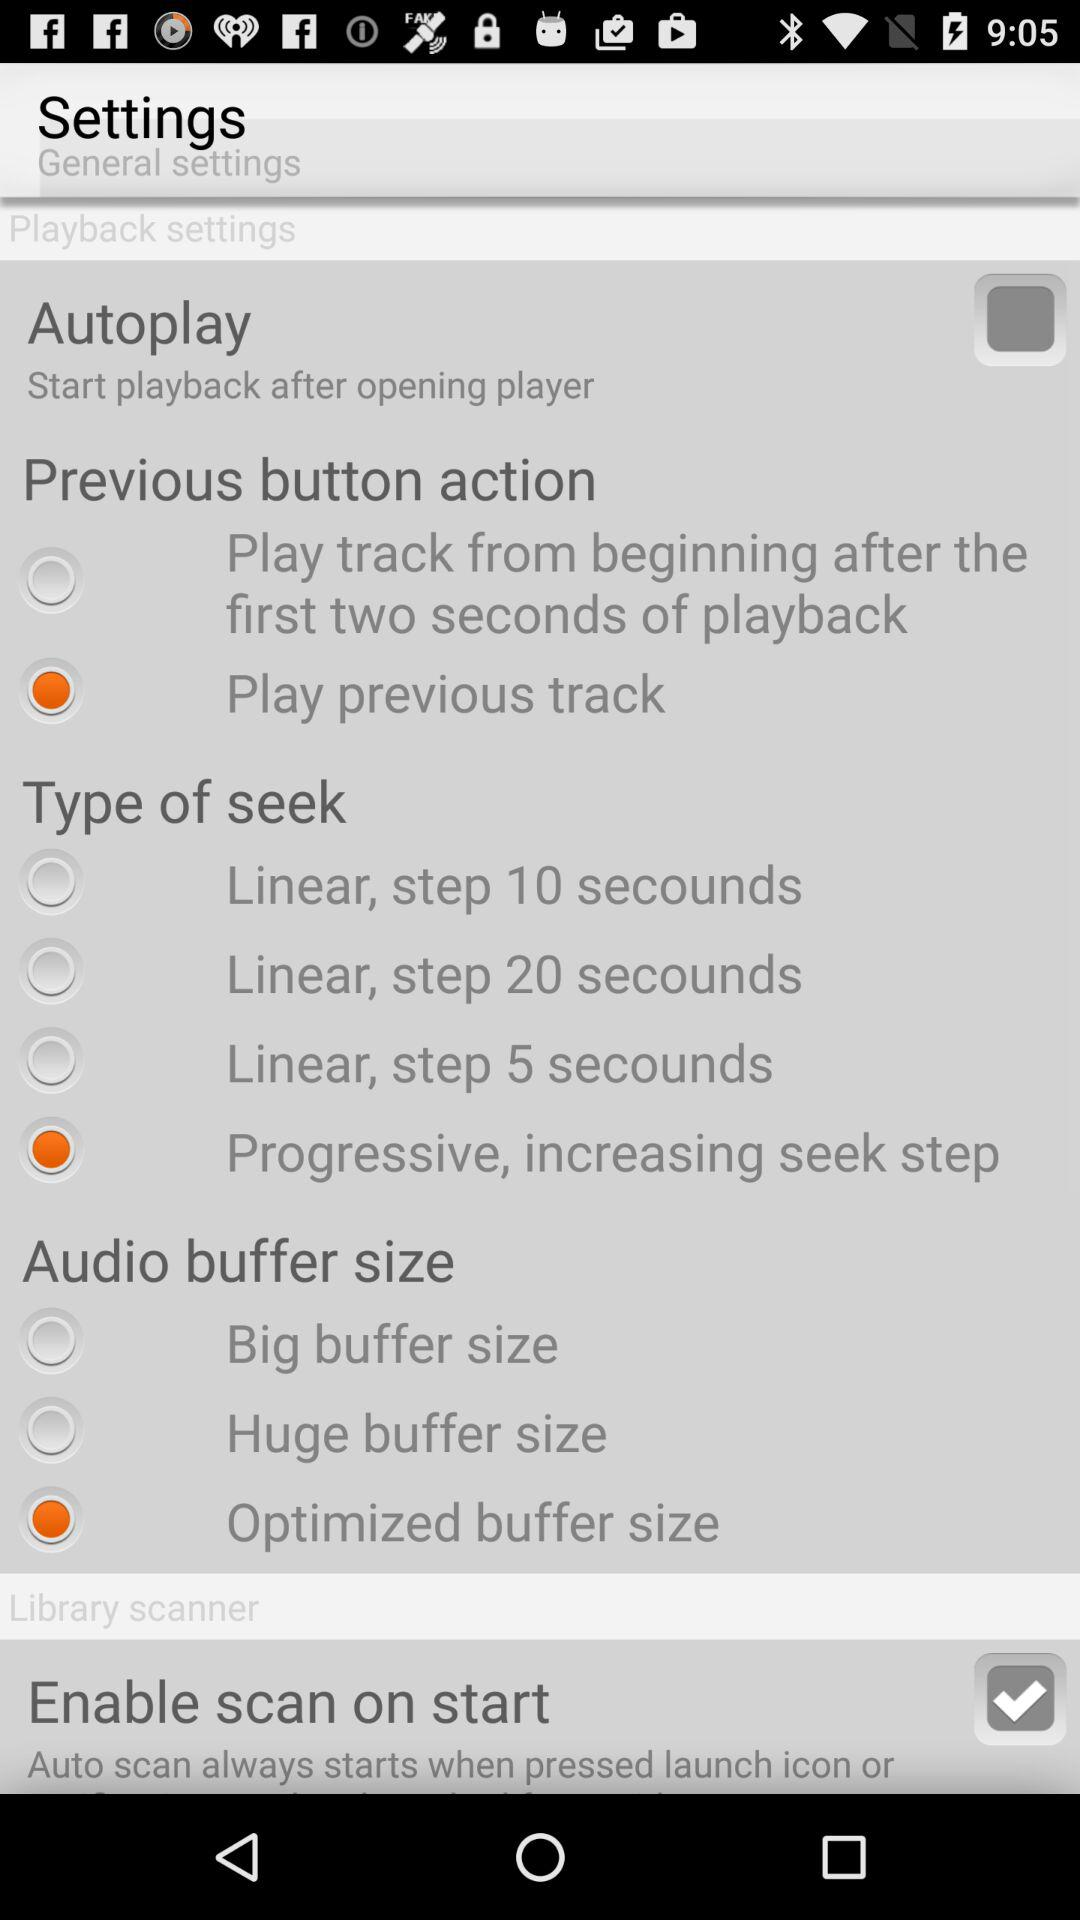Which option is selected in the "Previous button action"? The selected option in the "Previous button action" is "Play previous track". 